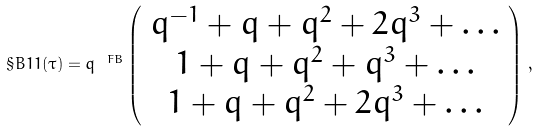<formula> <loc_0><loc_0><loc_500><loc_500>\S B { 1 } { 1 } ( \tau ) = q ^ { \ F B } \left ( \begin{array} { c } q ^ { - 1 } + q + q ^ { 2 } + 2 q ^ { 3 } + \dots \\ 1 + q + q ^ { 2 } + q ^ { 3 } + \dots \\ 1 + q + q ^ { 2 } + 2 q ^ { 3 } + \dots \end{array} \right ) \, ,</formula> 